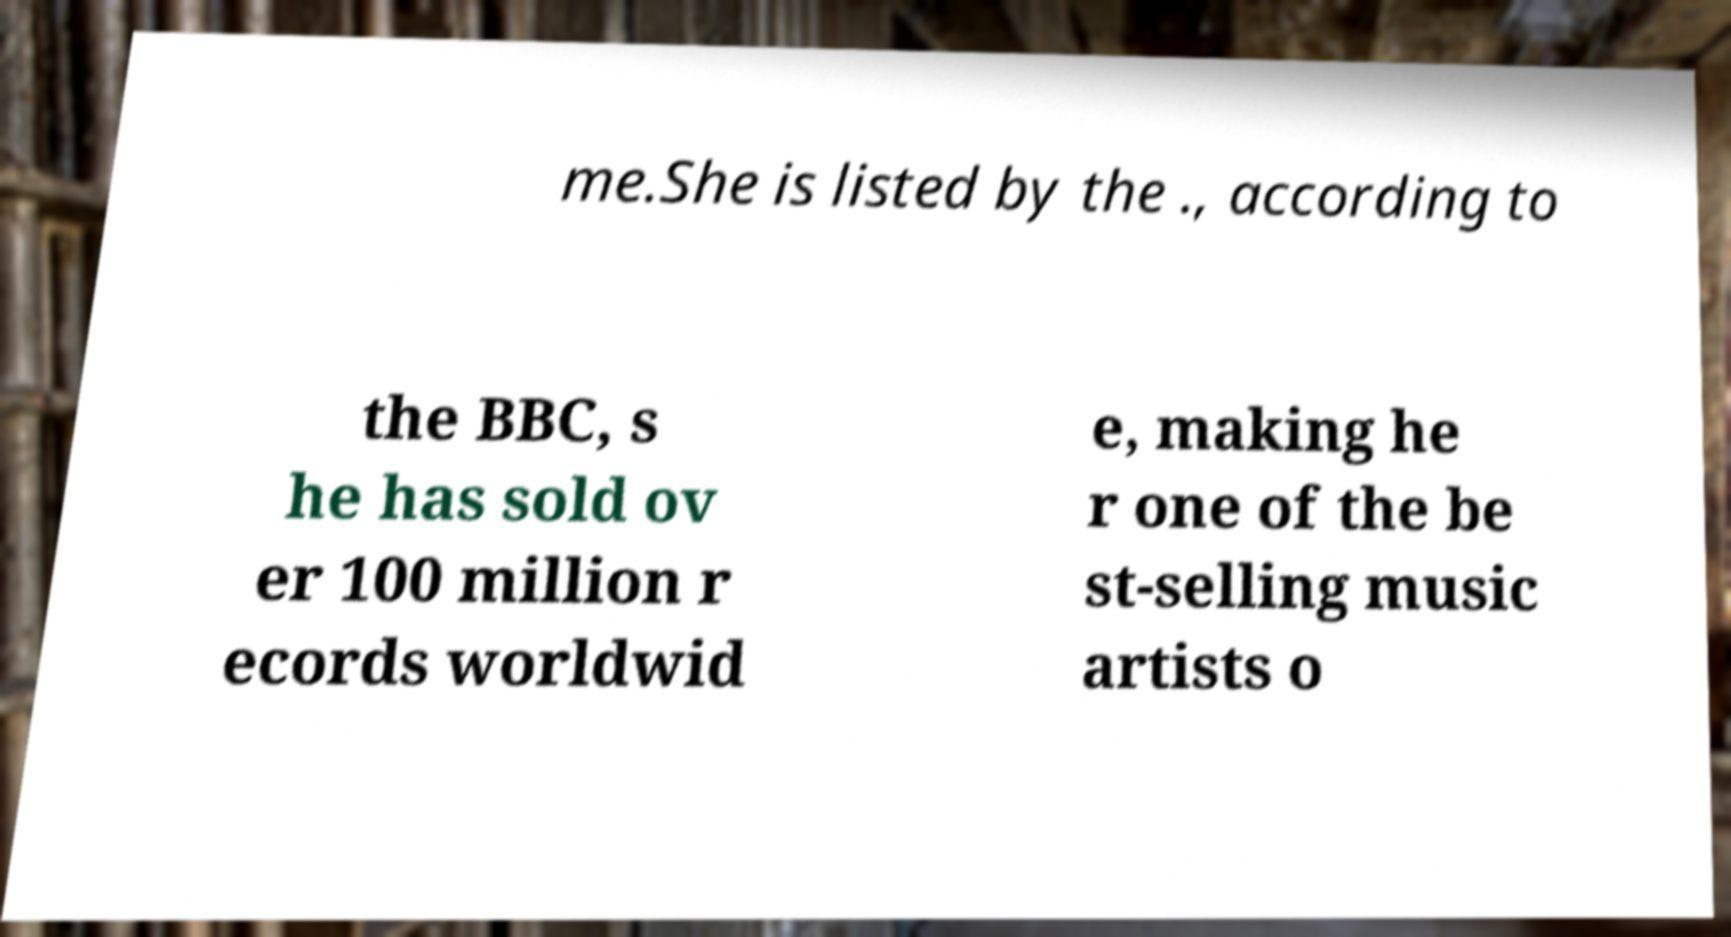Could you assist in decoding the text presented in this image and type it out clearly? me.She is listed by the ., according to the BBC, s he has sold ov er 100 million r ecords worldwid e, making he r one of the be st-selling music artists o 